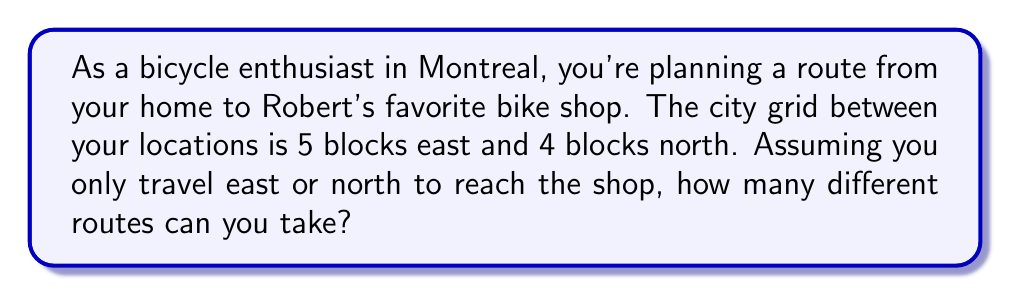Could you help me with this problem? Let's approach this step-by-step:

1) This problem is a classic application of combinatorics. We need to find the number of ways to arrange 5 east moves and 4 north moves.

2) The total number of moves is always 5 + 4 = 9, regardless of the route taken.

3) We can think of this as choosing which 5 of the 9 total moves will be east moves (or equivalently, which 4 will be north moves).

4) This is a combination problem. We're selecting 5 positions out of 9 for the east moves, which can be written as $\binom{9}{5}$ or $C(9,5)$.

5) The formula for this combination is:

   $$\binom{9}{5} = \frac{9!}{5!(9-5)!} = \frac{9!}{5!4!}$$

6) Let's calculate this:
   
   $$\frac{9 \times 8 \times 7 \times 6 \times 5!}{5! \times 4 \times 3 \times 2 \times 1}$$

7) The 5! cancels out in the numerator and denominator:

   $$\frac{9 \times 8 \times 7 \times 6}{4 \times 3 \times 2 \times 1} = \frac{3024}{24} = 126$$

Therefore, there are 126 different routes you can take to Robert's favorite bike shop.
Answer: 126 